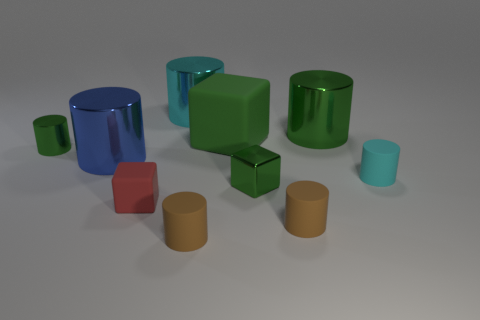Subtract all green cylinders. How many cylinders are left? 5 Subtract all cylinders. How many objects are left? 3 Subtract 1 cubes. How many cubes are left? 2 Subtract all green cubes. How many cubes are left? 1 Subtract 1 cyan cylinders. How many objects are left? 9 Subtract all cyan cylinders. Subtract all gray blocks. How many cylinders are left? 5 Subtract all yellow balls. How many purple cylinders are left? 0 Subtract all big objects. Subtract all small gray objects. How many objects are left? 6 Add 2 rubber cylinders. How many rubber cylinders are left? 5 Add 5 cyan metallic things. How many cyan metallic things exist? 6 